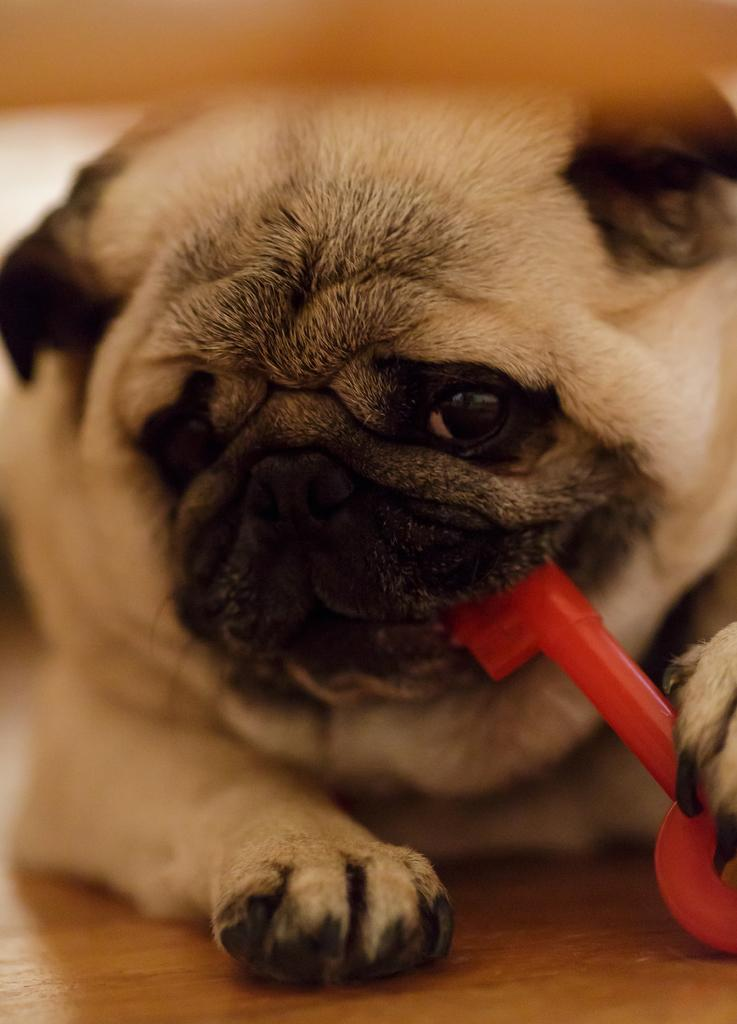What animal can be seen in the image? There is a dog in the image. What is the dog doing with its leg and mouth? The dog is holding a key with its leg and mouth. Can you describe the background of the image? The background of the image is blurry. What type of brush is the dog using to paint in the image? There is no brush or painting activity present in the image; the dog is holding a key. 